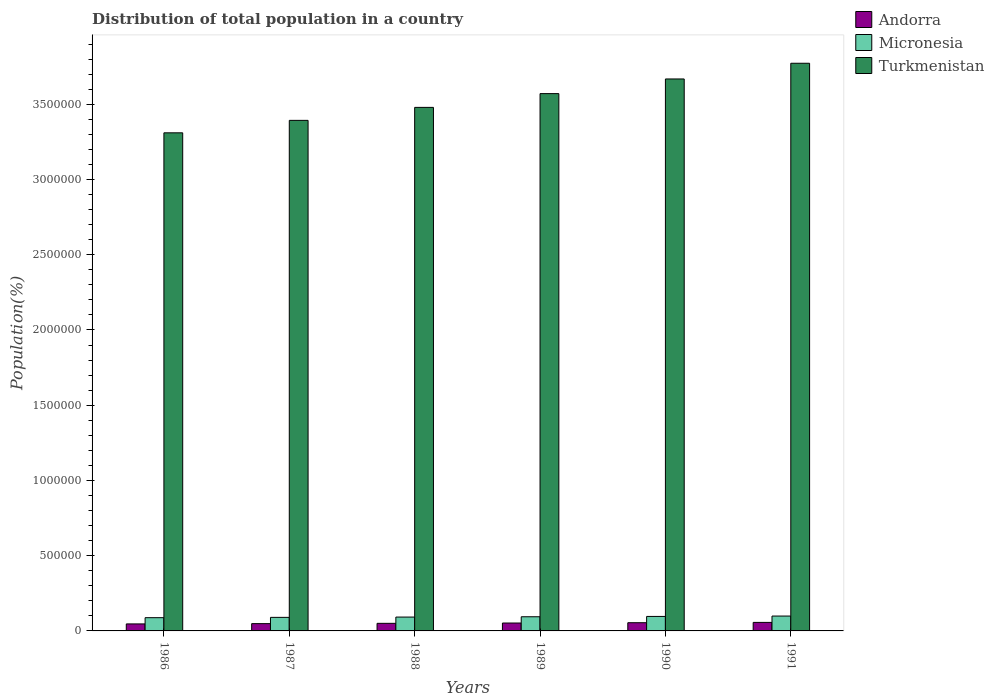How many different coloured bars are there?
Your response must be concise. 3. Are the number of bars per tick equal to the number of legend labels?
Offer a very short reply. Yes. How many bars are there on the 5th tick from the left?
Give a very brief answer. 3. What is the label of the 6th group of bars from the left?
Offer a very short reply. 1991. In how many cases, is the number of bars for a given year not equal to the number of legend labels?
Offer a terse response. 0. What is the population of in Andorra in 1986?
Keep it short and to the point. 4.65e+04. Across all years, what is the maximum population of in Turkmenistan?
Provide a short and direct response. 3.77e+06. Across all years, what is the minimum population of in Micronesia?
Provide a short and direct response. 8.79e+04. What is the total population of in Andorra in the graph?
Make the answer very short. 3.09e+05. What is the difference between the population of in Turkmenistan in 1986 and that in 1990?
Your response must be concise. -3.58e+05. What is the difference between the population of in Micronesia in 1988 and the population of in Andorra in 1989?
Keep it short and to the point. 3.96e+04. What is the average population of in Andorra per year?
Provide a succinct answer. 5.15e+04. In the year 1986, what is the difference between the population of in Andorra and population of in Micronesia?
Provide a succinct answer. -4.14e+04. In how many years, is the population of in Micronesia greater than 900000 %?
Give a very brief answer. 0. What is the ratio of the population of in Andorra in 1987 to that in 1990?
Make the answer very short. 0.89. Is the population of in Andorra in 1988 less than that in 1990?
Offer a very short reply. Yes. What is the difference between the highest and the second highest population of in Turkmenistan?
Your answer should be compact. 1.04e+05. What is the difference between the highest and the lowest population of in Turkmenistan?
Offer a very short reply. 4.62e+05. In how many years, is the population of in Andorra greater than the average population of in Andorra taken over all years?
Make the answer very short. 3. What does the 3rd bar from the left in 1987 represents?
Give a very brief answer. Turkmenistan. What does the 3rd bar from the right in 1989 represents?
Your answer should be very brief. Andorra. Are all the bars in the graph horizontal?
Give a very brief answer. No. Are the values on the major ticks of Y-axis written in scientific E-notation?
Your answer should be compact. No. Does the graph contain grids?
Your answer should be compact. No. What is the title of the graph?
Make the answer very short. Distribution of total population in a country. What is the label or title of the X-axis?
Keep it short and to the point. Years. What is the label or title of the Y-axis?
Your response must be concise. Population(%). What is the Population(%) of Andorra in 1986?
Provide a short and direct response. 4.65e+04. What is the Population(%) in Micronesia in 1986?
Your answer should be compact. 8.79e+04. What is the Population(%) of Turkmenistan in 1986?
Offer a very short reply. 3.31e+06. What is the Population(%) in Andorra in 1987?
Your response must be concise. 4.85e+04. What is the Population(%) in Micronesia in 1987?
Offer a terse response. 9.00e+04. What is the Population(%) in Turkmenistan in 1987?
Ensure brevity in your answer.  3.39e+06. What is the Population(%) of Andorra in 1988?
Offer a very short reply. 5.04e+04. What is the Population(%) of Micronesia in 1988?
Your answer should be compact. 9.20e+04. What is the Population(%) of Turkmenistan in 1988?
Provide a short and direct response. 3.48e+06. What is the Population(%) in Andorra in 1989?
Offer a very short reply. 5.24e+04. What is the Population(%) of Micronesia in 1989?
Make the answer very short. 9.41e+04. What is the Population(%) in Turkmenistan in 1989?
Your answer should be compact. 3.57e+06. What is the Population(%) in Andorra in 1990?
Ensure brevity in your answer.  5.45e+04. What is the Population(%) in Micronesia in 1990?
Ensure brevity in your answer.  9.63e+04. What is the Population(%) of Turkmenistan in 1990?
Ensure brevity in your answer.  3.67e+06. What is the Population(%) of Andorra in 1991?
Ensure brevity in your answer.  5.67e+04. What is the Population(%) of Micronesia in 1991?
Provide a succinct answer. 9.88e+04. What is the Population(%) in Turkmenistan in 1991?
Offer a terse response. 3.77e+06. Across all years, what is the maximum Population(%) in Andorra?
Give a very brief answer. 5.67e+04. Across all years, what is the maximum Population(%) of Micronesia?
Keep it short and to the point. 9.88e+04. Across all years, what is the maximum Population(%) in Turkmenistan?
Provide a succinct answer. 3.77e+06. Across all years, what is the minimum Population(%) of Andorra?
Provide a succinct answer. 4.65e+04. Across all years, what is the minimum Population(%) in Micronesia?
Ensure brevity in your answer.  8.79e+04. Across all years, what is the minimum Population(%) in Turkmenistan?
Provide a succinct answer. 3.31e+06. What is the total Population(%) in Andorra in the graph?
Provide a short and direct response. 3.09e+05. What is the total Population(%) of Micronesia in the graph?
Offer a very short reply. 5.59e+05. What is the total Population(%) in Turkmenistan in the graph?
Offer a terse response. 2.12e+07. What is the difference between the Population(%) in Andorra in 1986 and that in 1987?
Offer a very short reply. -1943. What is the difference between the Population(%) in Micronesia in 1986 and that in 1987?
Ensure brevity in your answer.  -2076. What is the difference between the Population(%) in Turkmenistan in 1986 and that in 1987?
Your answer should be compact. -8.28e+04. What is the difference between the Population(%) of Andorra in 1986 and that in 1988?
Your response must be concise. -3916. What is the difference between the Population(%) in Micronesia in 1986 and that in 1988?
Your response must be concise. -4072. What is the difference between the Population(%) in Turkmenistan in 1986 and that in 1988?
Offer a terse response. -1.69e+05. What is the difference between the Population(%) in Andorra in 1986 and that in 1989?
Make the answer very short. -5934. What is the difference between the Population(%) of Micronesia in 1986 and that in 1989?
Offer a terse response. -6143. What is the difference between the Population(%) of Turkmenistan in 1986 and that in 1989?
Your response must be concise. -2.60e+05. What is the difference between the Population(%) in Andorra in 1986 and that in 1990?
Your answer should be very brief. -7996. What is the difference between the Population(%) in Micronesia in 1986 and that in 1990?
Provide a short and direct response. -8383. What is the difference between the Population(%) in Turkmenistan in 1986 and that in 1990?
Offer a very short reply. -3.58e+05. What is the difference between the Population(%) in Andorra in 1986 and that in 1991?
Make the answer very short. -1.02e+04. What is the difference between the Population(%) of Micronesia in 1986 and that in 1991?
Offer a terse response. -1.09e+04. What is the difference between the Population(%) of Turkmenistan in 1986 and that in 1991?
Your response must be concise. -4.62e+05. What is the difference between the Population(%) of Andorra in 1987 and that in 1988?
Make the answer very short. -1973. What is the difference between the Population(%) in Micronesia in 1987 and that in 1988?
Provide a short and direct response. -1996. What is the difference between the Population(%) of Turkmenistan in 1987 and that in 1988?
Give a very brief answer. -8.63e+04. What is the difference between the Population(%) of Andorra in 1987 and that in 1989?
Ensure brevity in your answer.  -3991. What is the difference between the Population(%) in Micronesia in 1987 and that in 1989?
Give a very brief answer. -4067. What is the difference between the Population(%) of Turkmenistan in 1987 and that in 1989?
Keep it short and to the point. -1.78e+05. What is the difference between the Population(%) of Andorra in 1987 and that in 1990?
Make the answer very short. -6053. What is the difference between the Population(%) of Micronesia in 1987 and that in 1990?
Provide a succinct answer. -6307. What is the difference between the Population(%) in Turkmenistan in 1987 and that in 1990?
Make the answer very short. -2.75e+05. What is the difference between the Population(%) in Andorra in 1987 and that in 1991?
Provide a succinct answer. -8216. What is the difference between the Population(%) of Micronesia in 1987 and that in 1991?
Provide a short and direct response. -8776. What is the difference between the Population(%) in Turkmenistan in 1987 and that in 1991?
Your response must be concise. -3.80e+05. What is the difference between the Population(%) in Andorra in 1988 and that in 1989?
Give a very brief answer. -2018. What is the difference between the Population(%) in Micronesia in 1988 and that in 1989?
Your answer should be compact. -2071. What is the difference between the Population(%) of Turkmenistan in 1988 and that in 1989?
Your answer should be compact. -9.15e+04. What is the difference between the Population(%) of Andorra in 1988 and that in 1990?
Provide a succinct answer. -4080. What is the difference between the Population(%) in Micronesia in 1988 and that in 1990?
Ensure brevity in your answer.  -4311. What is the difference between the Population(%) of Turkmenistan in 1988 and that in 1990?
Give a very brief answer. -1.89e+05. What is the difference between the Population(%) in Andorra in 1988 and that in 1991?
Keep it short and to the point. -6243. What is the difference between the Population(%) of Micronesia in 1988 and that in 1991?
Keep it short and to the point. -6780. What is the difference between the Population(%) of Turkmenistan in 1988 and that in 1991?
Give a very brief answer. -2.93e+05. What is the difference between the Population(%) of Andorra in 1989 and that in 1990?
Make the answer very short. -2062. What is the difference between the Population(%) of Micronesia in 1989 and that in 1990?
Make the answer very short. -2240. What is the difference between the Population(%) in Turkmenistan in 1989 and that in 1990?
Your answer should be very brief. -9.74e+04. What is the difference between the Population(%) in Andorra in 1989 and that in 1991?
Your response must be concise. -4225. What is the difference between the Population(%) in Micronesia in 1989 and that in 1991?
Keep it short and to the point. -4709. What is the difference between the Population(%) of Turkmenistan in 1989 and that in 1991?
Offer a terse response. -2.02e+05. What is the difference between the Population(%) of Andorra in 1990 and that in 1991?
Provide a short and direct response. -2163. What is the difference between the Population(%) of Micronesia in 1990 and that in 1991?
Ensure brevity in your answer.  -2469. What is the difference between the Population(%) of Turkmenistan in 1990 and that in 1991?
Your answer should be compact. -1.04e+05. What is the difference between the Population(%) of Andorra in 1986 and the Population(%) of Micronesia in 1987?
Your response must be concise. -4.35e+04. What is the difference between the Population(%) in Andorra in 1986 and the Population(%) in Turkmenistan in 1987?
Your answer should be compact. -3.35e+06. What is the difference between the Population(%) in Micronesia in 1986 and the Population(%) in Turkmenistan in 1987?
Your answer should be compact. -3.30e+06. What is the difference between the Population(%) in Andorra in 1986 and the Population(%) in Micronesia in 1988?
Offer a terse response. -4.55e+04. What is the difference between the Population(%) of Andorra in 1986 and the Population(%) of Turkmenistan in 1988?
Give a very brief answer. -3.43e+06. What is the difference between the Population(%) in Micronesia in 1986 and the Population(%) in Turkmenistan in 1988?
Your response must be concise. -3.39e+06. What is the difference between the Population(%) in Andorra in 1986 and the Population(%) in Micronesia in 1989?
Keep it short and to the point. -4.76e+04. What is the difference between the Population(%) in Andorra in 1986 and the Population(%) in Turkmenistan in 1989?
Give a very brief answer. -3.52e+06. What is the difference between the Population(%) in Micronesia in 1986 and the Population(%) in Turkmenistan in 1989?
Your response must be concise. -3.48e+06. What is the difference between the Population(%) in Andorra in 1986 and the Population(%) in Micronesia in 1990?
Give a very brief answer. -4.98e+04. What is the difference between the Population(%) of Andorra in 1986 and the Population(%) of Turkmenistan in 1990?
Offer a terse response. -3.62e+06. What is the difference between the Population(%) in Micronesia in 1986 and the Population(%) in Turkmenistan in 1990?
Provide a succinct answer. -3.58e+06. What is the difference between the Population(%) in Andorra in 1986 and the Population(%) in Micronesia in 1991?
Your answer should be compact. -5.23e+04. What is the difference between the Population(%) of Andorra in 1986 and the Population(%) of Turkmenistan in 1991?
Offer a terse response. -3.73e+06. What is the difference between the Population(%) in Micronesia in 1986 and the Population(%) in Turkmenistan in 1991?
Make the answer very short. -3.68e+06. What is the difference between the Population(%) in Andorra in 1987 and the Population(%) in Micronesia in 1988?
Your answer should be very brief. -4.36e+04. What is the difference between the Population(%) in Andorra in 1987 and the Population(%) in Turkmenistan in 1988?
Provide a short and direct response. -3.43e+06. What is the difference between the Population(%) of Micronesia in 1987 and the Population(%) of Turkmenistan in 1988?
Keep it short and to the point. -3.39e+06. What is the difference between the Population(%) of Andorra in 1987 and the Population(%) of Micronesia in 1989?
Offer a very short reply. -4.56e+04. What is the difference between the Population(%) in Andorra in 1987 and the Population(%) in Turkmenistan in 1989?
Your answer should be compact. -3.52e+06. What is the difference between the Population(%) of Micronesia in 1987 and the Population(%) of Turkmenistan in 1989?
Provide a succinct answer. -3.48e+06. What is the difference between the Population(%) in Andorra in 1987 and the Population(%) in Micronesia in 1990?
Make the answer very short. -4.79e+04. What is the difference between the Population(%) in Andorra in 1987 and the Population(%) in Turkmenistan in 1990?
Offer a terse response. -3.62e+06. What is the difference between the Population(%) in Micronesia in 1987 and the Population(%) in Turkmenistan in 1990?
Give a very brief answer. -3.58e+06. What is the difference between the Population(%) in Andorra in 1987 and the Population(%) in Micronesia in 1991?
Give a very brief answer. -5.03e+04. What is the difference between the Population(%) in Andorra in 1987 and the Population(%) in Turkmenistan in 1991?
Your answer should be very brief. -3.72e+06. What is the difference between the Population(%) of Micronesia in 1987 and the Population(%) of Turkmenistan in 1991?
Ensure brevity in your answer.  -3.68e+06. What is the difference between the Population(%) in Andorra in 1988 and the Population(%) in Micronesia in 1989?
Make the answer very short. -4.37e+04. What is the difference between the Population(%) of Andorra in 1988 and the Population(%) of Turkmenistan in 1989?
Offer a very short reply. -3.52e+06. What is the difference between the Population(%) of Micronesia in 1988 and the Population(%) of Turkmenistan in 1989?
Your answer should be very brief. -3.48e+06. What is the difference between the Population(%) of Andorra in 1988 and the Population(%) of Micronesia in 1990?
Provide a succinct answer. -4.59e+04. What is the difference between the Population(%) of Andorra in 1988 and the Population(%) of Turkmenistan in 1990?
Your response must be concise. -3.62e+06. What is the difference between the Population(%) in Micronesia in 1988 and the Population(%) in Turkmenistan in 1990?
Provide a short and direct response. -3.58e+06. What is the difference between the Population(%) in Andorra in 1988 and the Population(%) in Micronesia in 1991?
Your answer should be very brief. -4.84e+04. What is the difference between the Population(%) of Andorra in 1988 and the Population(%) of Turkmenistan in 1991?
Give a very brief answer. -3.72e+06. What is the difference between the Population(%) in Micronesia in 1988 and the Population(%) in Turkmenistan in 1991?
Your answer should be compact. -3.68e+06. What is the difference between the Population(%) in Andorra in 1989 and the Population(%) in Micronesia in 1990?
Provide a short and direct response. -4.39e+04. What is the difference between the Population(%) of Andorra in 1989 and the Population(%) of Turkmenistan in 1990?
Your response must be concise. -3.62e+06. What is the difference between the Population(%) of Micronesia in 1989 and the Population(%) of Turkmenistan in 1990?
Provide a succinct answer. -3.57e+06. What is the difference between the Population(%) of Andorra in 1989 and the Population(%) of Micronesia in 1991?
Give a very brief answer. -4.64e+04. What is the difference between the Population(%) of Andorra in 1989 and the Population(%) of Turkmenistan in 1991?
Provide a succinct answer. -3.72e+06. What is the difference between the Population(%) of Micronesia in 1989 and the Population(%) of Turkmenistan in 1991?
Your response must be concise. -3.68e+06. What is the difference between the Population(%) in Andorra in 1990 and the Population(%) in Micronesia in 1991?
Provide a short and direct response. -4.43e+04. What is the difference between the Population(%) of Andorra in 1990 and the Population(%) of Turkmenistan in 1991?
Ensure brevity in your answer.  -3.72e+06. What is the difference between the Population(%) of Micronesia in 1990 and the Population(%) of Turkmenistan in 1991?
Give a very brief answer. -3.68e+06. What is the average Population(%) in Andorra per year?
Give a very brief answer. 5.15e+04. What is the average Population(%) in Micronesia per year?
Keep it short and to the point. 9.32e+04. What is the average Population(%) in Turkmenistan per year?
Keep it short and to the point. 3.53e+06. In the year 1986, what is the difference between the Population(%) in Andorra and Population(%) in Micronesia?
Give a very brief answer. -4.14e+04. In the year 1986, what is the difference between the Population(%) of Andorra and Population(%) of Turkmenistan?
Offer a terse response. -3.26e+06. In the year 1986, what is the difference between the Population(%) of Micronesia and Population(%) of Turkmenistan?
Offer a terse response. -3.22e+06. In the year 1987, what is the difference between the Population(%) of Andorra and Population(%) of Micronesia?
Provide a succinct answer. -4.16e+04. In the year 1987, what is the difference between the Population(%) of Andorra and Population(%) of Turkmenistan?
Give a very brief answer. -3.34e+06. In the year 1987, what is the difference between the Population(%) of Micronesia and Population(%) of Turkmenistan?
Provide a short and direct response. -3.30e+06. In the year 1988, what is the difference between the Population(%) of Andorra and Population(%) of Micronesia?
Make the answer very short. -4.16e+04. In the year 1988, what is the difference between the Population(%) in Andorra and Population(%) in Turkmenistan?
Offer a very short reply. -3.43e+06. In the year 1988, what is the difference between the Population(%) in Micronesia and Population(%) in Turkmenistan?
Provide a succinct answer. -3.39e+06. In the year 1989, what is the difference between the Population(%) of Andorra and Population(%) of Micronesia?
Offer a terse response. -4.16e+04. In the year 1989, what is the difference between the Population(%) of Andorra and Population(%) of Turkmenistan?
Give a very brief answer. -3.52e+06. In the year 1989, what is the difference between the Population(%) of Micronesia and Population(%) of Turkmenistan?
Make the answer very short. -3.48e+06. In the year 1990, what is the difference between the Population(%) in Andorra and Population(%) in Micronesia?
Provide a succinct answer. -4.18e+04. In the year 1990, what is the difference between the Population(%) of Andorra and Population(%) of Turkmenistan?
Ensure brevity in your answer.  -3.61e+06. In the year 1990, what is the difference between the Population(%) in Micronesia and Population(%) in Turkmenistan?
Your response must be concise. -3.57e+06. In the year 1991, what is the difference between the Population(%) of Andorra and Population(%) of Micronesia?
Give a very brief answer. -4.21e+04. In the year 1991, what is the difference between the Population(%) of Andorra and Population(%) of Turkmenistan?
Provide a short and direct response. -3.72e+06. In the year 1991, what is the difference between the Population(%) of Micronesia and Population(%) of Turkmenistan?
Offer a very short reply. -3.67e+06. What is the ratio of the Population(%) in Andorra in 1986 to that in 1987?
Provide a succinct answer. 0.96. What is the ratio of the Population(%) of Micronesia in 1986 to that in 1987?
Provide a short and direct response. 0.98. What is the ratio of the Population(%) in Turkmenistan in 1986 to that in 1987?
Offer a terse response. 0.98. What is the ratio of the Population(%) in Andorra in 1986 to that in 1988?
Offer a terse response. 0.92. What is the ratio of the Population(%) in Micronesia in 1986 to that in 1988?
Make the answer very short. 0.96. What is the ratio of the Population(%) in Turkmenistan in 1986 to that in 1988?
Your answer should be very brief. 0.95. What is the ratio of the Population(%) in Andorra in 1986 to that in 1989?
Offer a terse response. 0.89. What is the ratio of the Population(%) of Micronesia in 1986 to that in 1989?
Your response must be concise. 0.93. What is the ratio of the Population(%) in Turkmenistan in 1986 to that in 1989?
Provide a short and direct response. 0.93. What is the ratio of the Population(%) in Andorra in 1986 to that in 1990?
Provide a short and direct response. 0.85. What is the ratio of the Population(%) in Micronesia in 1986 to that in 1990?
Offer a very short reply. 0.91. What is the ratio of the Population(%) of Turkmenistan in 1986 to that in 1990?
Your response must be concise. 0.9. What is the ratio of the Population(%) of Andorra in 1986 to that in 1991?
Provide a succinct answer. 0.82. What is the ratio of the Population(%) in Micronesia in 1986 to that in 1991?
Your response must be concise. 0.89. What is the ratio of the Population(%) of Turkmenistan in 1986 to that in 1991?
Give a very brief answer. 0.88. What is the ratio of the Population(%) of Andorra in 1987 to that in 1988?
Your response must be concise. 0.96. What is the ratio of the Population(%) of Micronesia in 1987 to that in 1988?
Keep it short and to the point. 0.98. What is the ratio of the Population(%) of Turkmenistan in 1987 to that in 1988?
Your answer should be compact. 0.98. What is the ratio of the Population(%) of Andorra in 1987 to that in 1989?
Your answer should be compact. 0.92. What is the ratio of the Population(%) in Micronesia in 1987 to that in 1989?
Give a very brief answer. 0.96. What is the ratio of the Population(%) of Turkmenistan in 1987 to that in 1989?
Provide a succinct answer. 0.95. What is the ratio of the Population(%) in Andorra in 1987 to that in 1990?
Ensure brevity in your answer.  0.89. What is the ratio of the Population(%) in Micronesia in 1987 to that in 1990?
Offer a very short reply. 0.93. What is the ratio of the Population(%) of Turkmenistan in 1987 to that in 1990?
Your answer should be compact. 0.93. What is the ratio of the Population(%) in Andorra in 1987 to that in 1991?
Ensure brevity in your answer.  0.85. What is the ratio of the Population(%) in Micronesia in 1987 to that in 1991?
Offer a very short reply. 0.91. What is the ratio of the Population(%) of Turkmenistan in 1987 to that in 1991?
Keep it short and to the point. 0.9. What is the ratio of the Population(%) in Andorra in 1988 to that in 1989?
Offer a terse response. 0.96. What is the ratio of the Population(%) in Turkmenistan in 1988 to that in 1989?
Provide a short and direct response. 0.97. What is the ratio of the Population(%) of Andorra in 1988 to that in 1990?
Offer a very short reply. 0.93. What is the ratio of the Population(%) in Micronesia in 1988 to that in 1990?
Offer a very short reply. 0.96. What is the ratio of the Population(%) of Turkmenistan in 1988 to that in 1990?
Provide a short and direct response. 0.95. What is the ratio of the Population(%) of Andorra in 1988 to that in 1991?
Make the answer very short. 0.89. What is the ratio of the Population(%) of Micronesia in 1988 to that in 1991?
Provide a short and direct response. 0.93. What is the ratio of the Population(%) of Turkmenistan in 1988 to that in 1991?
Provide a short and direct response. 0.92. What is the ratio of the Population(%) in Andorra in 1989 to that in 1990?
Your answer should be very brief. 0.96. What is the ratio of the Population(%) of Micronesia in 1989 to that in 1990?
Ensure brevity in your answer.  0.98. What is the ratio of the Population(%) of Turkmenistan in 1989 to that in 1990?
Offer a very short reply. 0.97. What is the ratio of the Population(%) of Andorra in 1989 to that in 1991?
Your response must be concise. 0.93. What is the ratio of the Population(%) of Micronesia in 1989 to that in 1991?
Make the answer very short. 0.95. What is the ratio of the Population(%) of Turkmenistan in 1989 to that in 1991?
Your response must be concise. 0.95. What is the ratio of the Population(%) in Andorra in 1990 to that in 1991?
Make the answer very short. 0.96. What is the ratio of the Population(%) in Turkmenistan in 1990 to that in 1991?
Ensure brevity in your answer.  0.97. What is the difference between the highest and the second highest Population(%) of Andorra?
Offer a terse response. 2163. What is the difference between the highest and the second highest Population(%) of Micronesia?
Give a very brief answer. 2469. What is the difference between the highest and the second highest Population(%) of Turkmenistan?
Keep it short and to the point. 1.04e+05. What is the difference between the highest and the lowest Population(%) in Andorra?
Offer a terse response. 1.02e+04. What is the difference between the highest and the lowest Population(%) of Micronesia?
Your answer should be compact. 1.09e+04. What is the difference between the highest and the lowest Population(%) in Turkmenistan?
Give a very brief answer. 4.62e+05. 